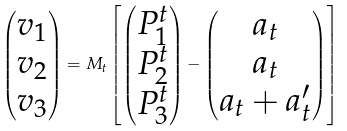<formula> <loc_0><loc_0><loc_500><loc_500>\begin{pmatrix} v _ { 1 } \\ v _ { 2 } \\ v _ { 3 } \end{pmatrix} = M _ { t } \left [ \begin{pmatrix} P ^ { t } _ { 1 } \\ P ^ { t } _ { 2 } \\ P ^ { t } _ { 3 } \end{pmatrix} - \begin{pmatrix} a _ { t } \\ a _ { t } \\ a _ { t } + a ^ { \prime } _ { t } \end{pmatrix} \right ]</formula> 